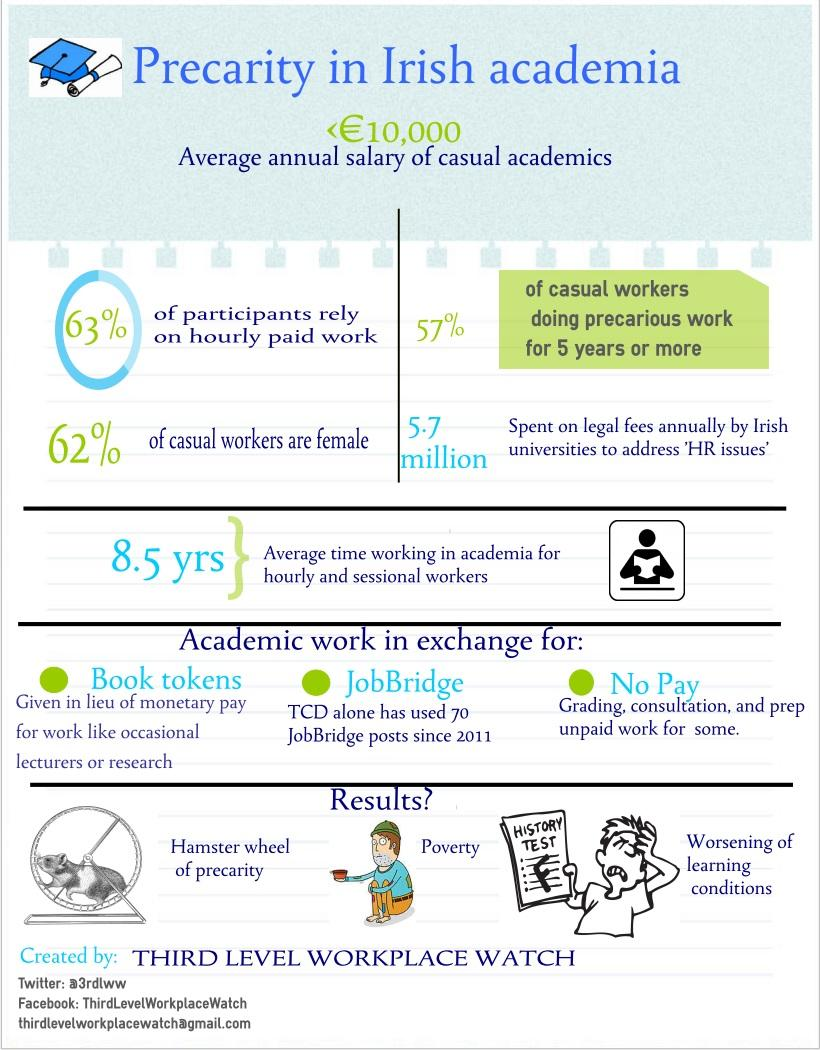Specify some key components in this picture. A recent study in Irish academia has revealed that 38% of casual workers are male. It was found that approximately 37% of participants in Irish academia do not rely on hourly paid work. 